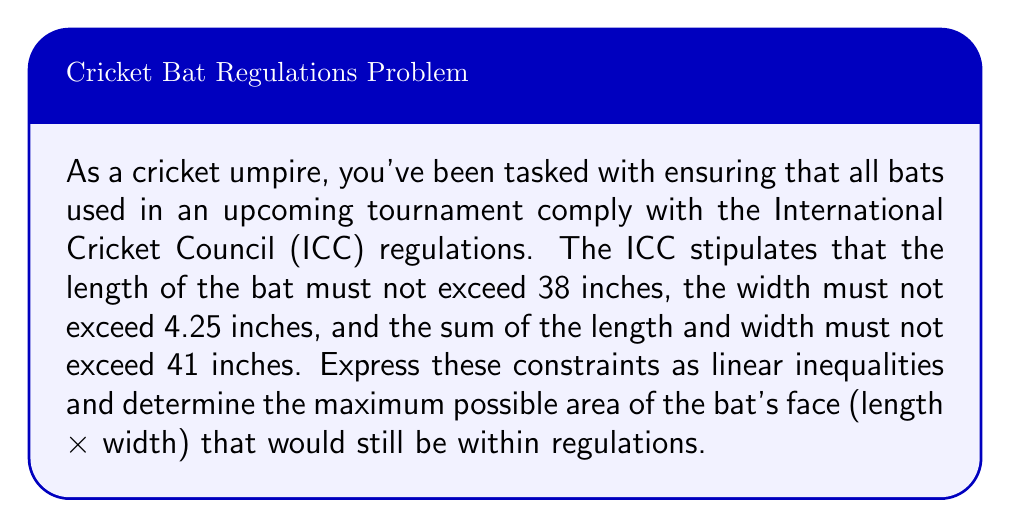Can you answer this question? Let's approach this step-by-step:

1) Let $l$ represent the length of the bat in inches and $w$ represent the width in inches.

2) We can express the ICC regulations as linear inequalities:
   
   Length constraint: $l \leq 38$
   Width constraint: $w \leq 4.25$
   Sum constraint: $l + w \leq 41$

3) We're looking to maximize the area of the bat's face, which is given by $A = l \times w$.

4) To find the maximum area, we need to consider the vertices of the feasible region defined by our inequalities. The potential vertices are:

   $(38, 3)$ : Where the length constraint meets the sum constraint
   $(36.75, 4.25)$ : Where the width constraint meets the sum constraint
   $(38, 4.25)$ : Where the length and width constraints meet

5) Let's calculate the area for each of these points:

   $A_1 = 38 \times 3 = 114$ sq inches
   $A_2 = 36.75 \times 4.25 = 156.1875$ sq inches
   $A_3 = 38 \times 4.25 = 161.5$ sq inches

6) The maximum area is achieved at the point $(38, 4.25)$, which represents a bat with maximum allowed length and width.

Therefore, the maximum possible area of the bat's face while staying within ICC regulations is 161.5 square inches.
Answer: The maximum possible area of the bat's face is 161.5 square inches, achieved with dimensions of 38 inches in length and 4.25 inches in width. 